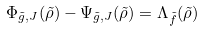<formula> <loc_0><loc_0><loc_500><loc_500>\Phi _ { \tilde { g } , J } ( \tilde { \rho } ) - \Psi _ { \tilde { g } , J } ( \tilde { \rho } ) = \Lambda _ { \tilde { f } } ( \tilde { \rho } )</formula> 